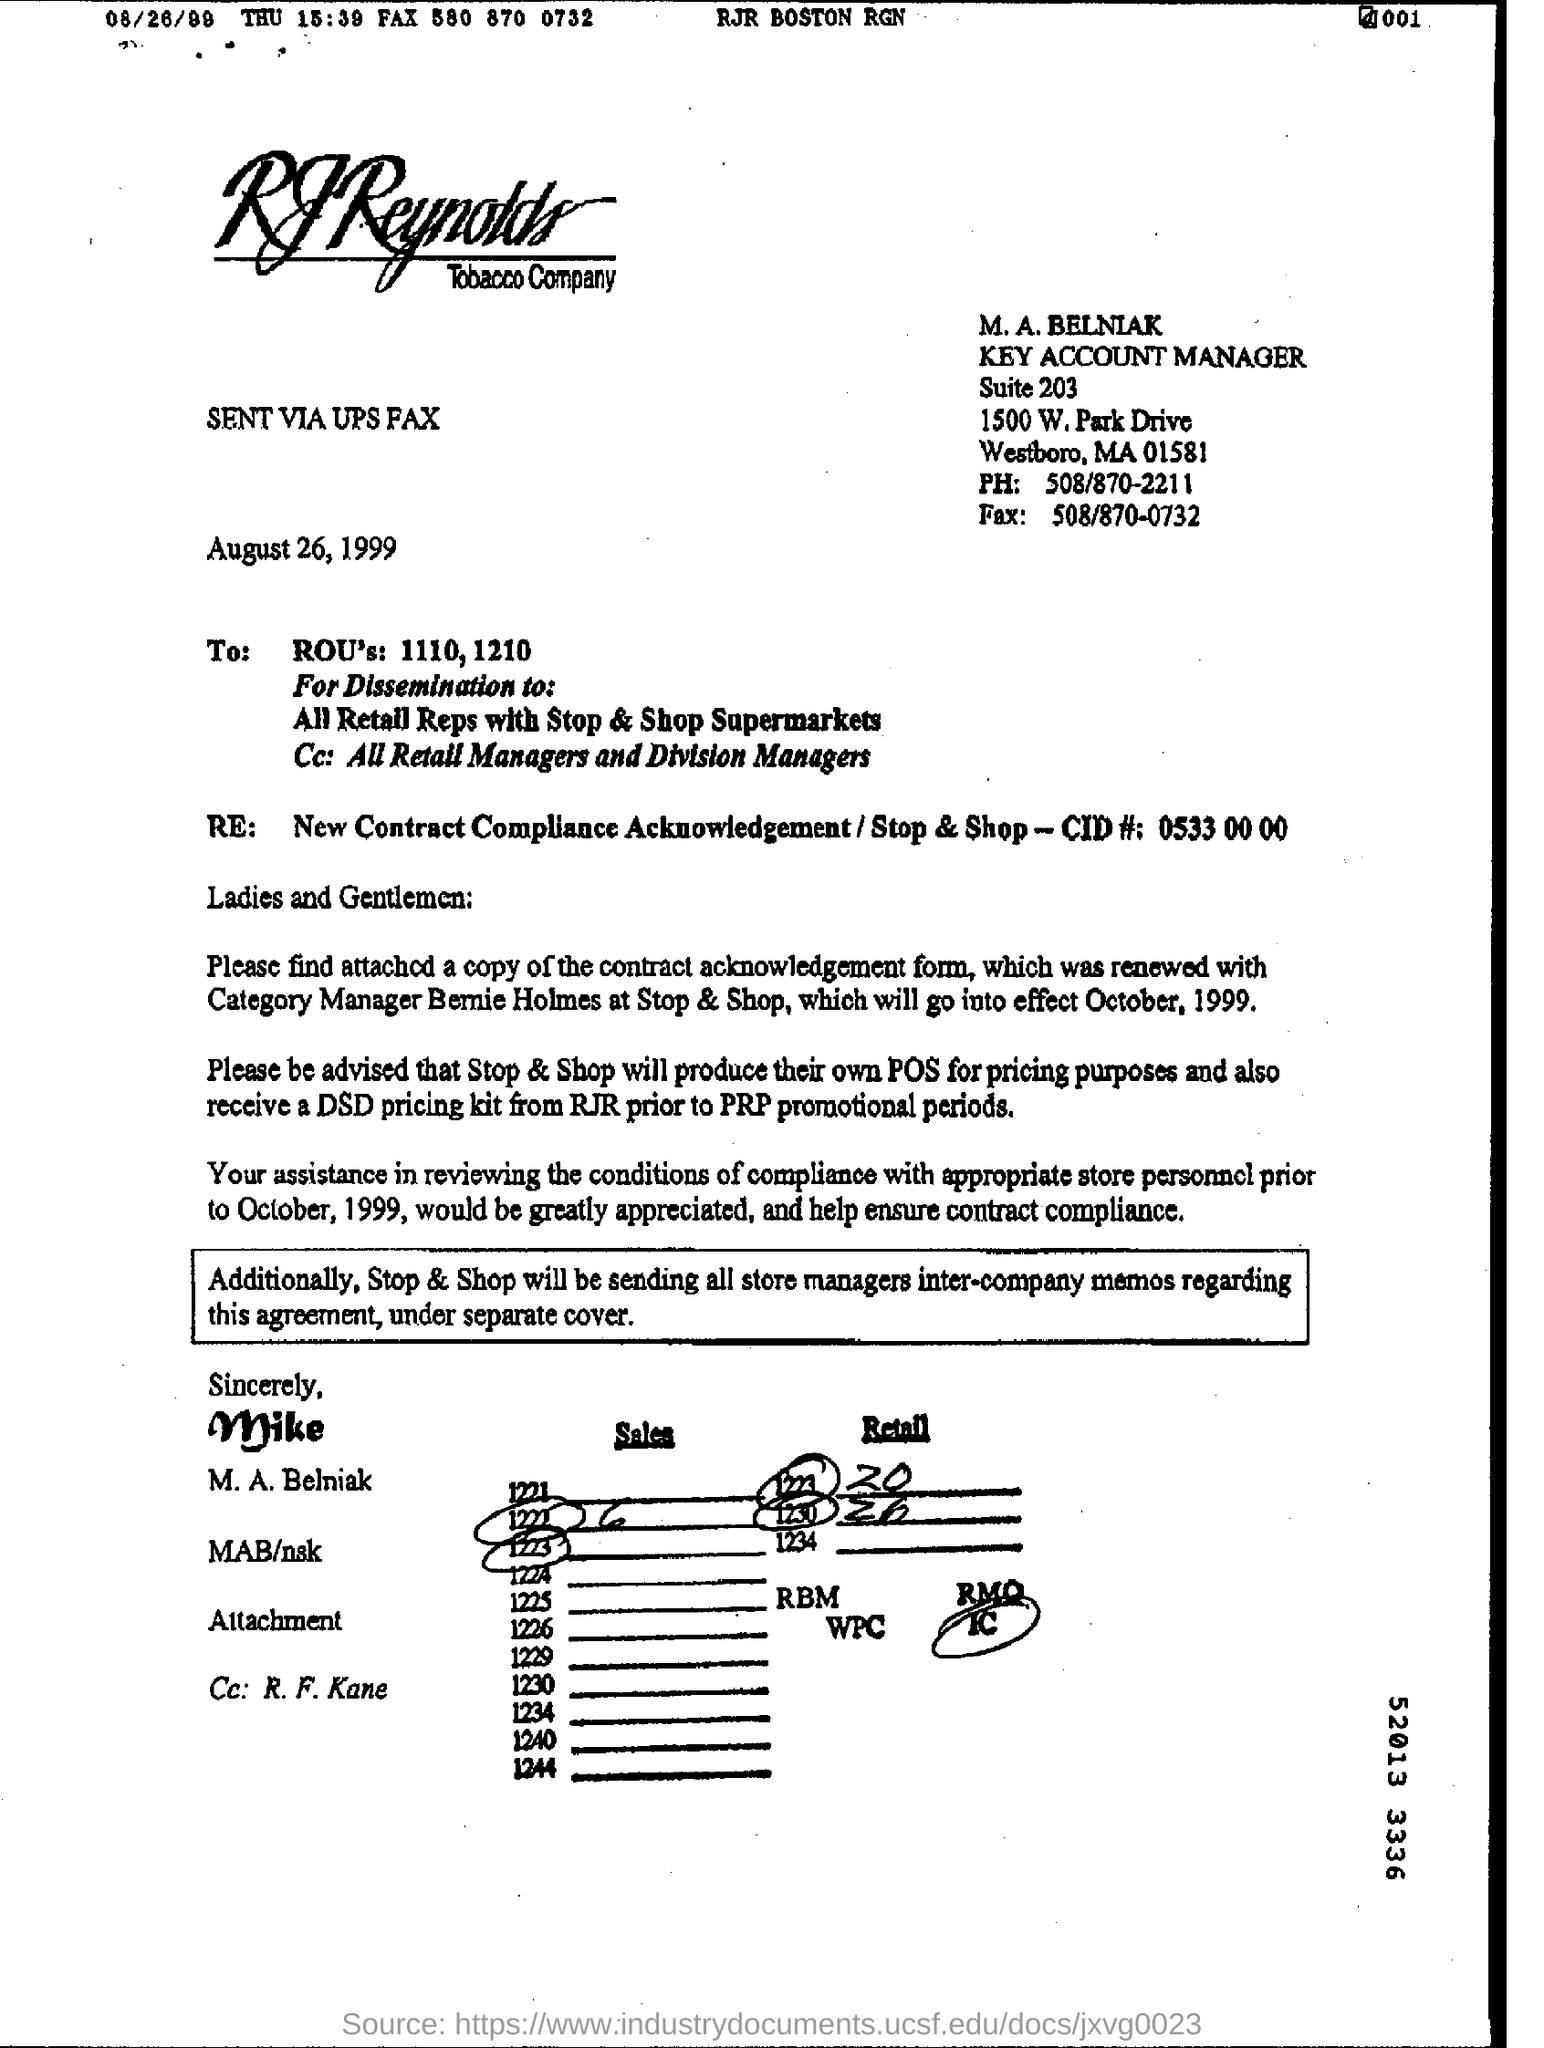Indicate a few pertinent items in this graphic. The fax number is 508/870-0732. The Key Account Manager is M.A. BELNIAK. The company in question is R.J. Reynolds Tobacco Company. The suite number is 203. August 26, 1999 is the date of this communication. 